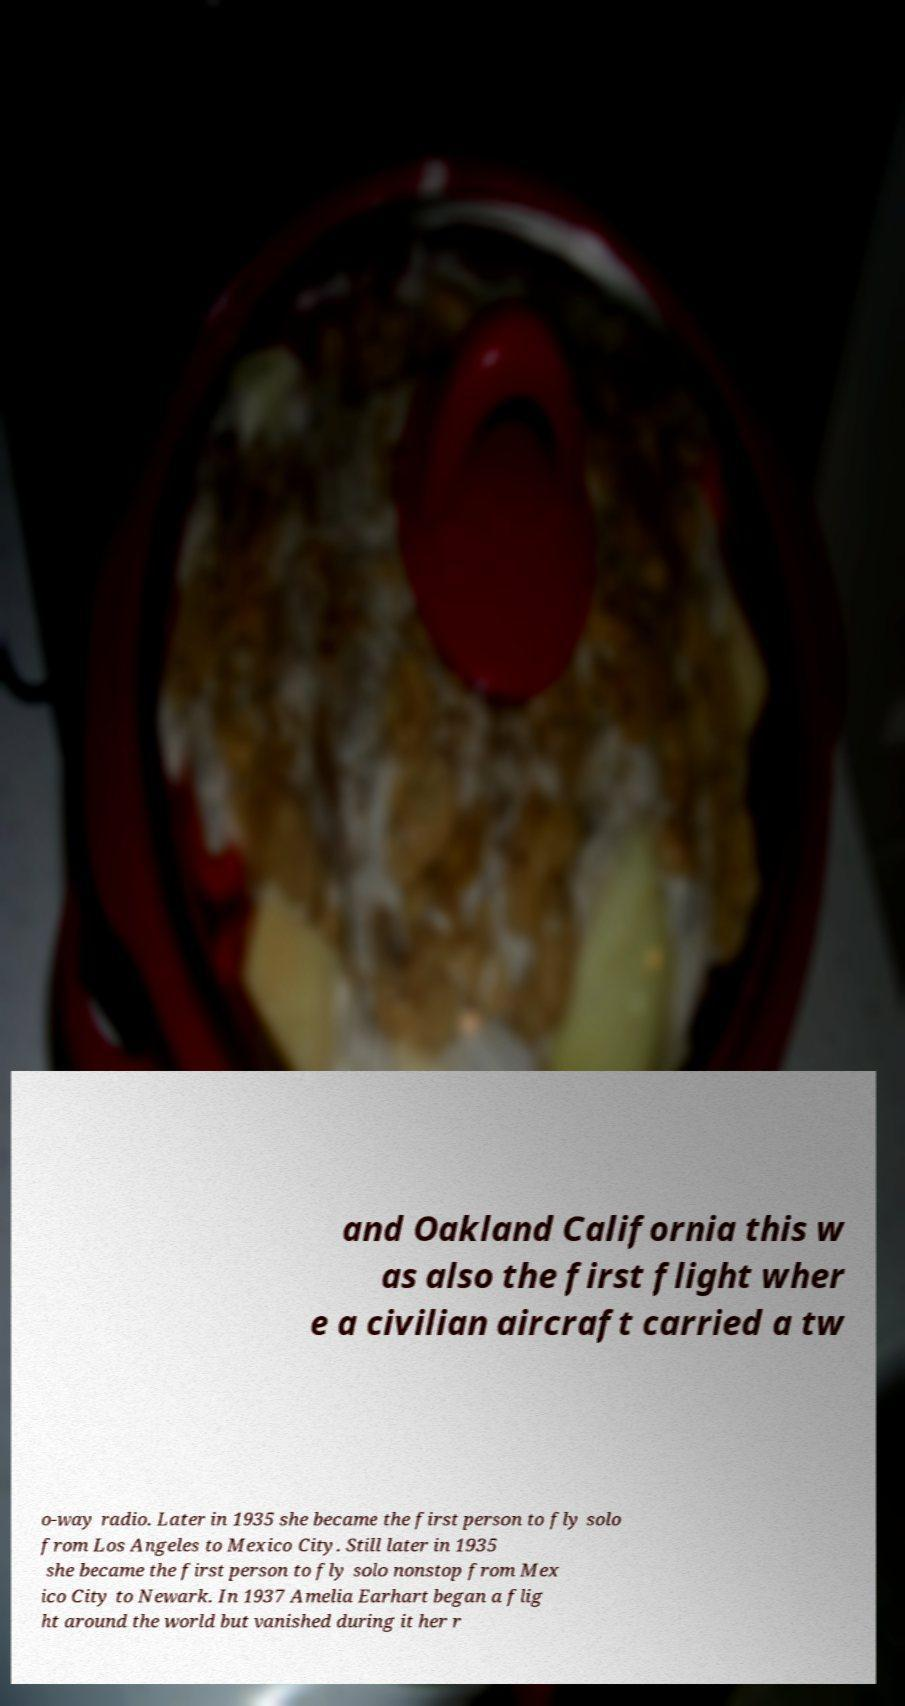For documentation purposes, I need the text within this image transcribed. Could you provide that? and Oakland California this w as also the first flight wher e a civilian aircraft carried a tw o-way radio. Later in 1935 she became the first person to fly solo from Los Angeles to Mexico City. Still later in 1935 she became the first person to fly solo nonstop from Mex ico City to Newark. In 1937 Amelia Earhart began a flig ht around the world but vanished during it her r 